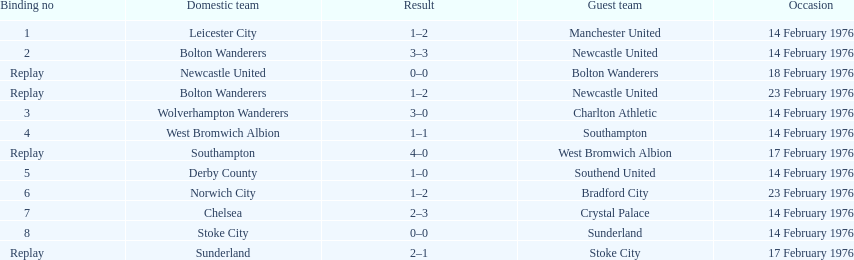How many of these games occurred before 17 february 1976? 7. 